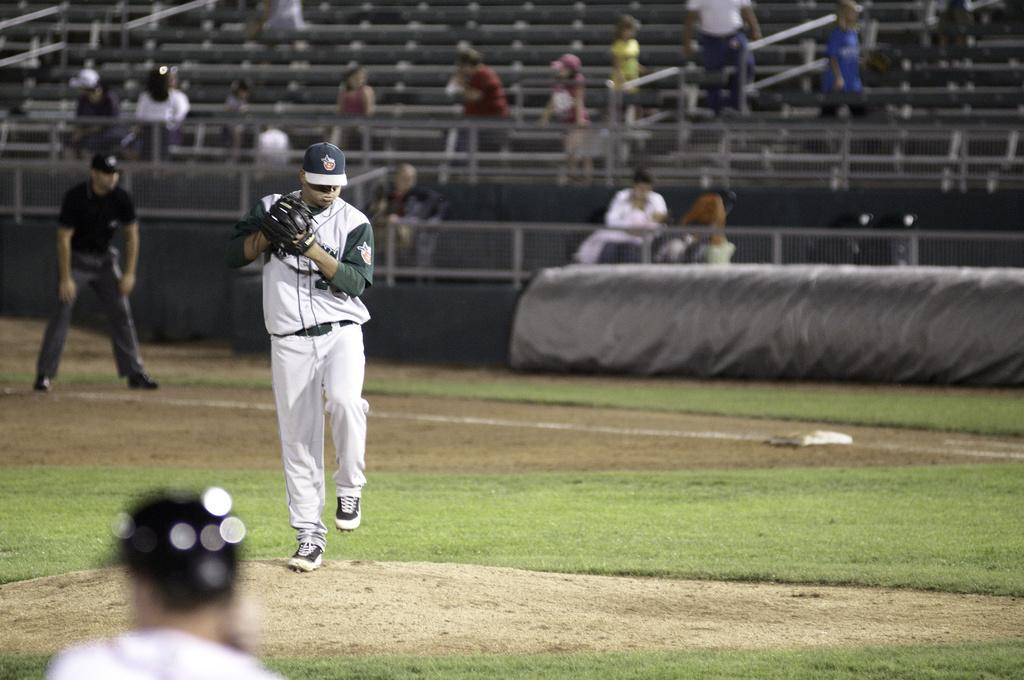How many people are visible in the image? There are three people in the image. What are the two men in the image doing? The two men are standing on the ground. Can you describe the background of the image? There are people, railings, and objects in the background of the image. What type of orange can be seen in the image? There is no orange present in the image. How many geese are visible in the image? There are no geese visible in the image. 